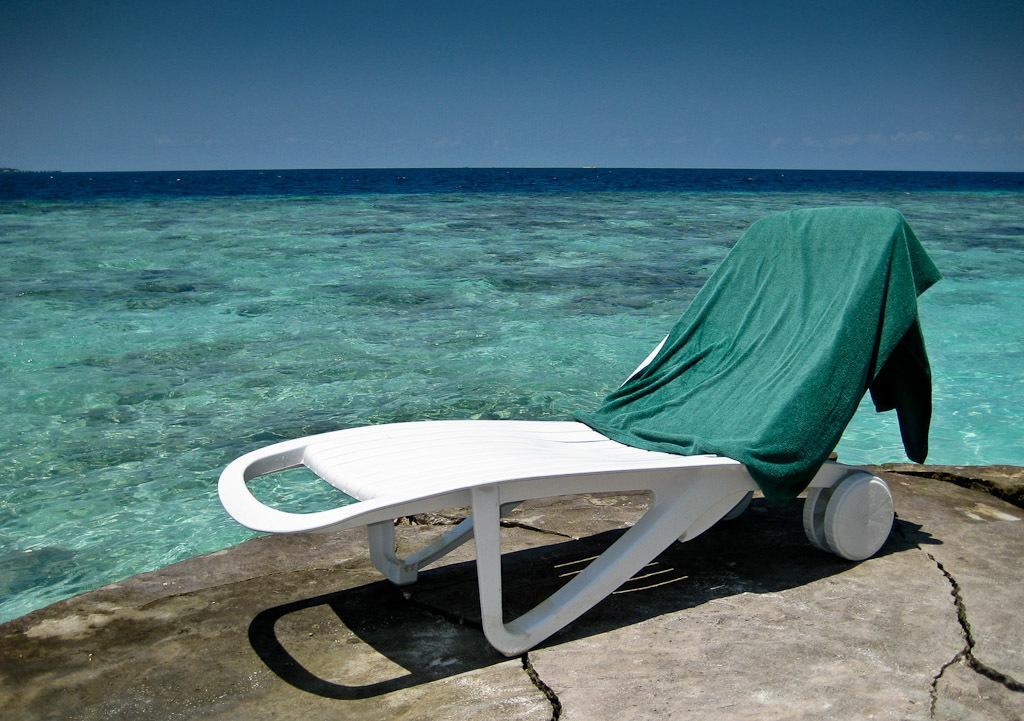How would you summarize this image in a sentence or two? In this image, we can see cloth on the chair. There is a sea in the middle of the image. There is a sky at the top of the image. 